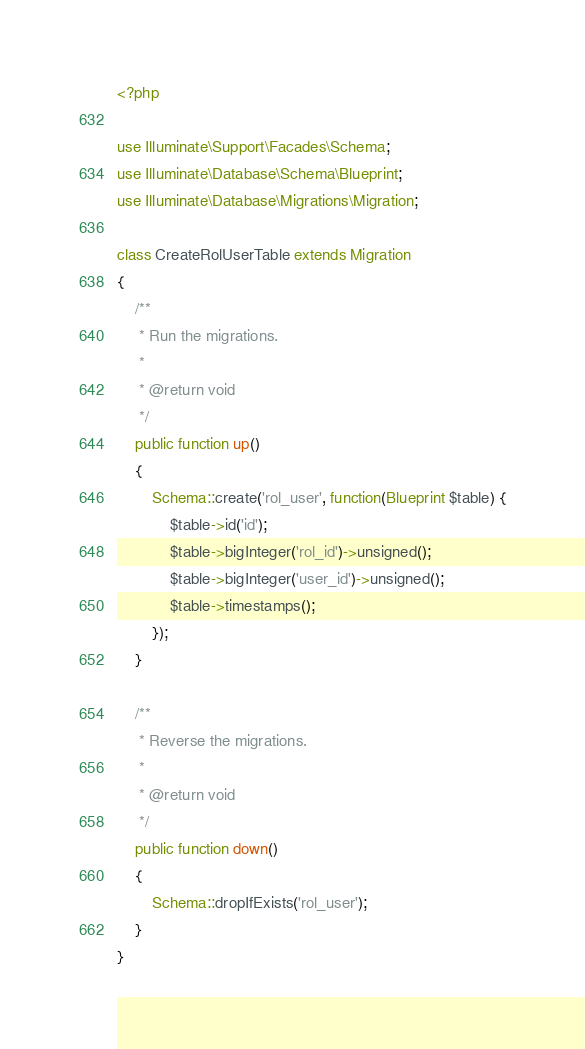Convert code to text. <code><loc_0><loc_0><loc_500><loc_500><_PHP_><?php

use Illuminate\Support\Facades\Schema;
use Illuminate\Database\Schema\Blueprint;
use Illuminate\Database\Migrations\Migration;

class CreateRolUserTable extends Migration
{
    /**
     * Run the migrations.
     *
     * @return void
     */
    public function up()
    {
        Schema::create('rol_user', function(Blueprint $table) {
            $table->id('id');
            $table->bigInteger('rol_id')->unsigned();
            $table->bigInteger('user_id')->unsigned();
            $table->timestamps();
        });
    }

    /**
     * Reverse the migrations.
     *
     * @return void
     */
    public function down()
    {
        Schema::dropIfExists('rol_user');
    }
}
</code> 